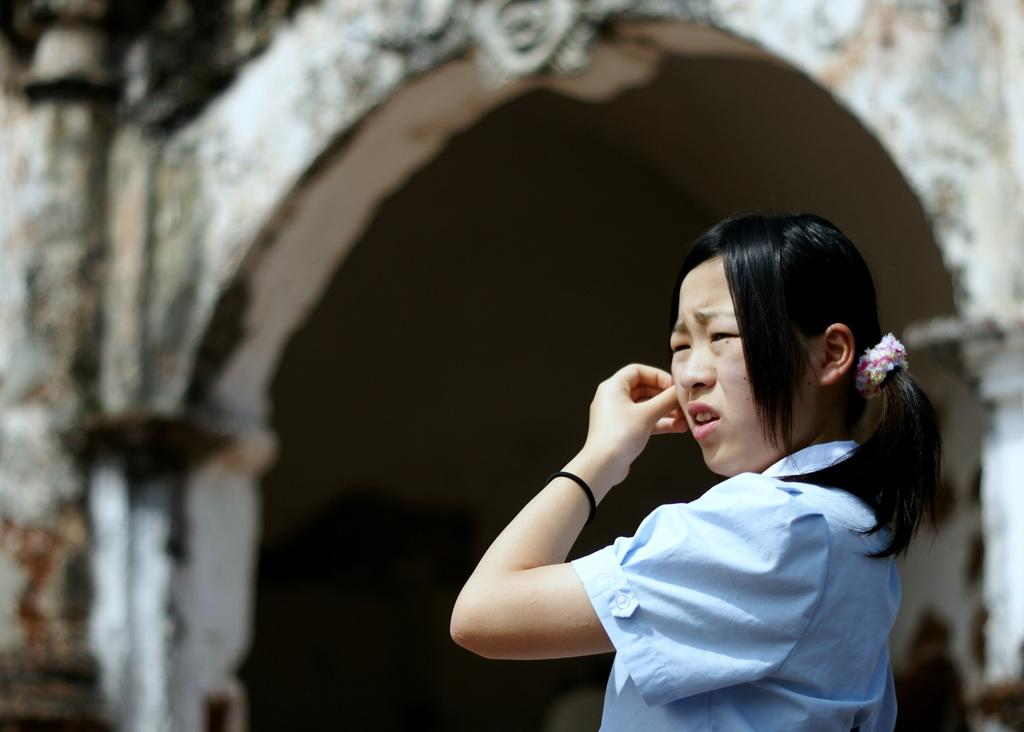Who is the main subject in the image? There is a girl in the image. What can be seen in the background of the image? There is an arch and pillars in the background of the image. How would you describe the background of the image? The background is blurry. What type of jam is being served at the party in the image? There is no party or jam present in the image; it features a girl with a blurry background. 